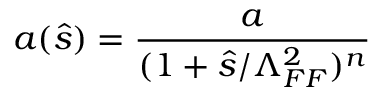Convert formula to latex. <formula><loc_0><loc_0><loc_500><loc_500>a ( \hat { s } ) = { \frac { a } { ( 1 + \hat { s } / \Lambda _ { F F } ^ { 2 } ) ^ { n } } }</formula> 